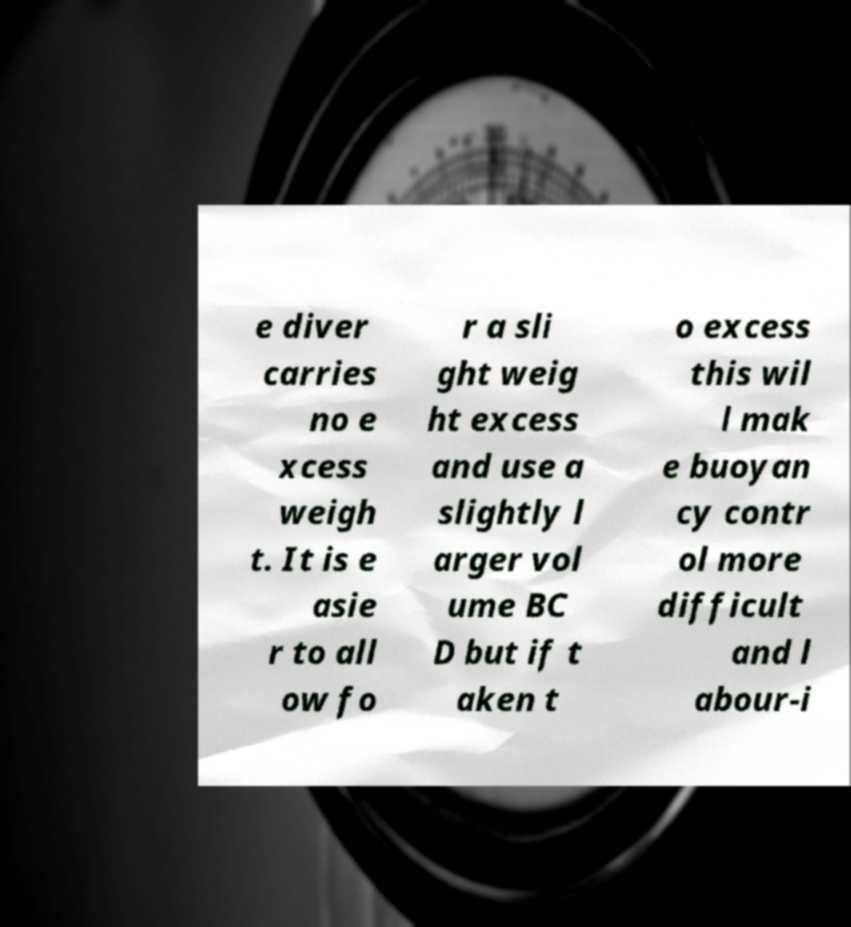For documentation purposes, I need the text within this image transcribed. Could you provide that? e diver carries no e xcess weigh t. It is e asie r to all ow fo r a sli ght weig ht excess and use a slightly l arger vol ume BC D but if t aken t o excess this wil l mak e buoyan cy contr ol more difficult and l abour-i 